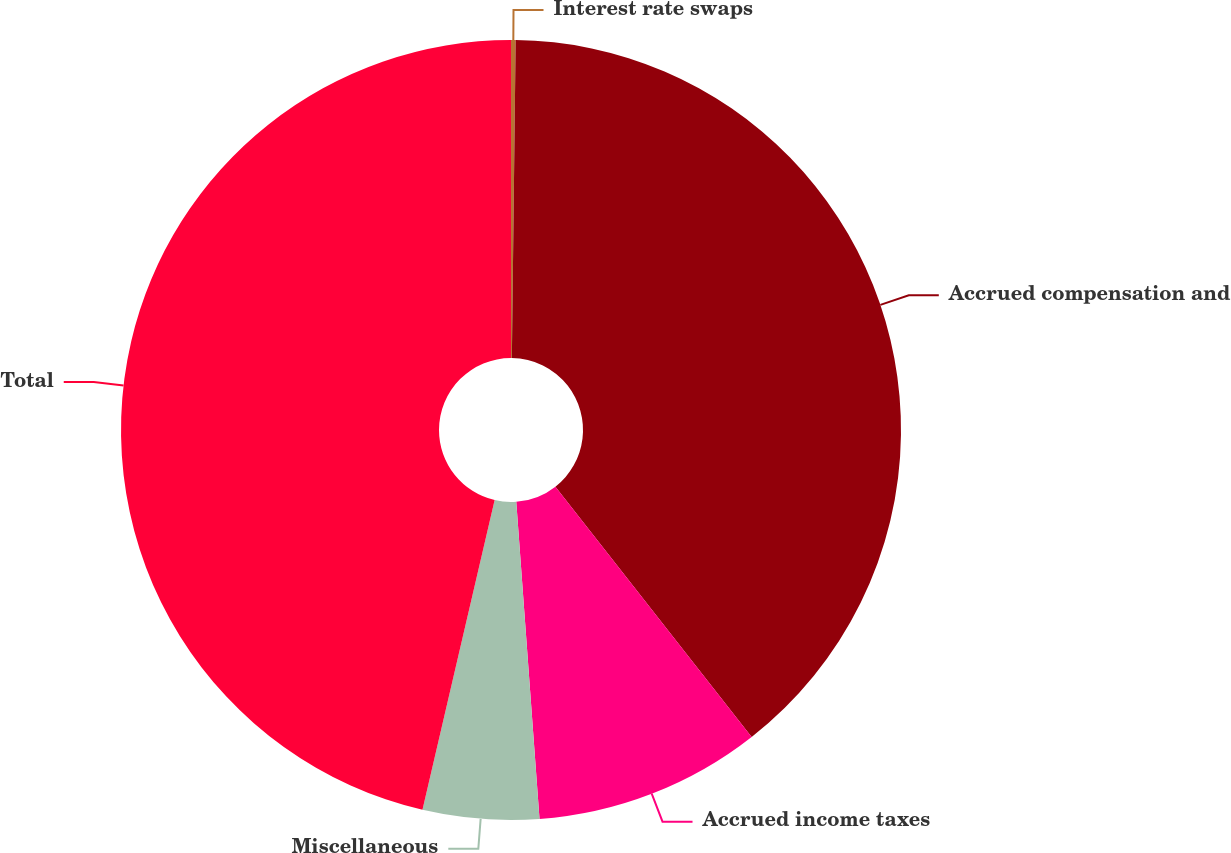Convert chart to OTSL. <chart><loc_0><loc_0><loc_500><loc_500><pie_chart><fcel>Interest rate swaps<fcel>Accrued compensation and<fcel>Accrued income taxes<fcel>Miscellaneous<fcel>Total<nl><fcel>0.19%<fcel>39.23%<fcel>9.42%<fcel>4.81%<fcel>46.36%<nl></chart> 